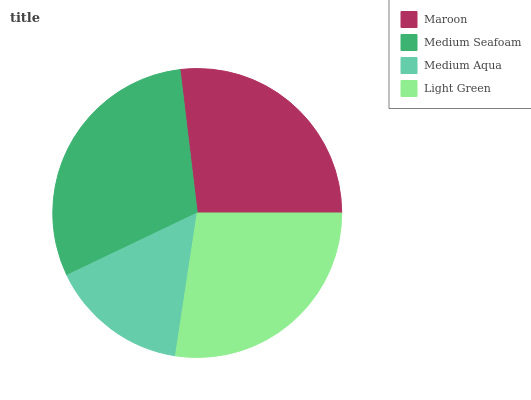Is Medium Aqua the minimum?
Answer yes or no. Yes. Is Medium Seafoam the maximum?
Answer yes or no. Yes. Is Medium Seafoam the minimum?
Answer yes or no. No. Is Medium Aqua the maximum?
Answer yes or no. No. Is Medium Seafoam greater than Medium Aqua?
Answer yes or no. Yes. Is Medium Aqua less than Medium Seafoam?
Answer yes or no. Yes. Is Medium Aqua greater than Medium Seafoam?
Answer yes or no. No. Is Medium Seafoam less than Medium Aqua?
Answer yes or no. No. Is Light Green the high median?
Answer yes or no. Yes. Is Maroon the low median?
Answer yes or no. Yes. Is Medium Seafoam the high median?
Answer yes or no. No. Is Medium Aqua the low median?
Answer yes or no. No. 